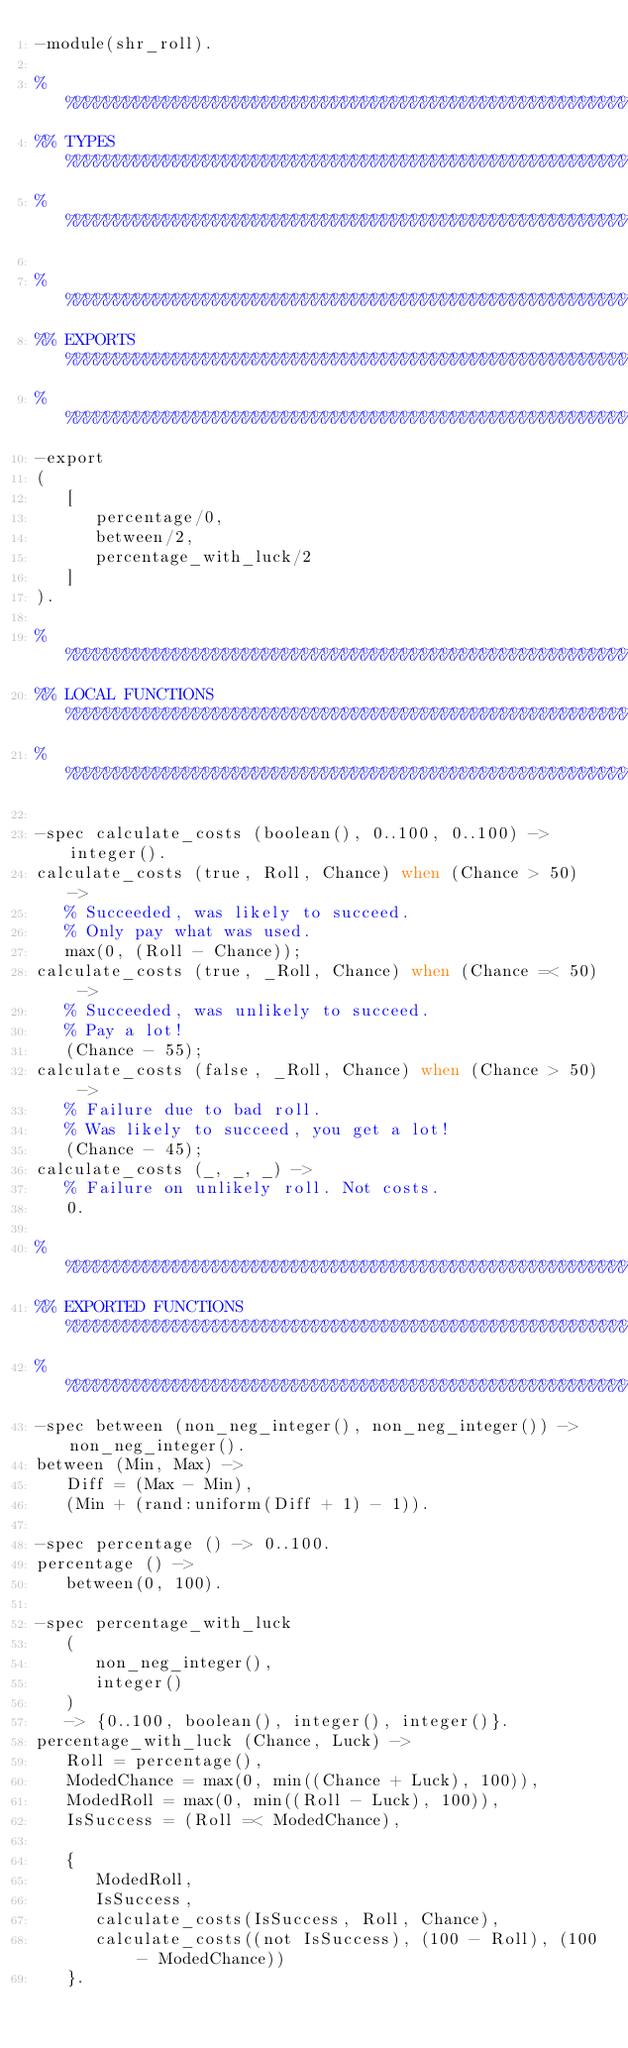<code> <loc_0><loc_0><loc_500><loc_500><_Erlang_>-module(shr_roll).

%%%%%%%%%%%%%%%%%%%%%%%%%%%%%%%%%%%%%%%%%%%%%%%%%%%%%%%%%%%%%%%%%%%%%%%%%%%%%%%%
%% TYPES %%%%%%%%%%%%%%%%%%%%%%%%%%%%%%%%%%%%%%%%%%%%%%%%%%%%%%%%%%%%%%%%%%%%%%%
%%%%%%%%%%%%%%%%%%%%%%%%%%%%%%%%%%%%%%%%%%%%%%%%%%%%%%%%%%%%%%%%%%%%%%%%%%%%%%%%

%%%%%%%%%%%%%%%%%%%%%%%%%%%%%%%%%%%%%%%%%%%%%%%%%%%%%%%%%%%%%%%%%%%%%%%%%%%%%%%%
%% EXPORTS %%%%%%%%%%%%%%%%%%%%%%%%%%%%%%%%%%%%%%%%%%%%%%%%%%%%%%%%%%%%%%%%%%%%%
%%%%%%%%%%%%%%%%%%%%%%%%%%%%%%%%%%%%%%%%%%%%%%%%%%%%%%%%%%%%%%%%%%%%%%%%%%%%%%%%
-export
(
   [
      percentage/0,
      between/2,
      percentage_with_luck/2
   ]
).

%%%%%%%%%%%%%%%%%%%%%%%%%%%%%%%%%%%%%%%%%%%%%%%%%%%%%%%%%%%%%%%%%%%%%%%%%%%%%%%%
%% LOCAL FUNCTIONS %%%%%%%%%%%%%%%%%%%%%%%%%%%%%%%%%%%%%%%%%%%%%%%%%%%%%%%%%%%%%
%%%%%%%%%%%%%%%%%%%%%%%%%%%%%%%%%%%%%%%%%%%%%%%%%%%%%%%%%%%%%%%%%%%%%%%%%%%%%%%%

-spec calculate_costs (boolean(), 0..100, 0..100) -> integer().
calculate_costs (true, Roll, Chance) when (Chance > 50) ->
   % Succeeded, was likely to succeed.
   % Only pay what was used.
   max(0, (Roll - Chance));
calculate_costs (true, _Roll, Chance) when (Chance =< 50) ->
   % Succeeded, was unlikely to succeed.
   % Pay a lot!
   (Chance - 55);
calculate_costs (false, _Roll, Chance) when (Chance > 50) ->
   % Failure due to bad roll.
   % Was likely to succeed, you get a lot!
   (Chance - 45);
calculate_costs (_, _, _) ->
   % Failure on unlikely roll. Not costs.
   0.

%%%%%%%%%%%%%%%%%%%%%%%%%%%%%%%%%%%%%%%%%%%%%%%%%%%%%%%%%%%%%%%%%%%%%%%%%%%%%%%%
%% EXPORTED FUNCTIONS %%%%%%%%%%%%%%%%%%%%%%%%%%%%%%%%%%%%%%%%%%%%%%%%%%%%%%%%%%
%%%%%%%%%%%%%%%%%%%%%%%%%%%%%%%%%%%%%%%%%%%%%%%%%%%%%%%%%%%%%%%%%%%%%%%%%%%%%%%%
-spec between (non_neg_integer(), non_neg_integer()) -> non_neg_integer().
between (Min, Max) ->
   Diff = (Max - Min),
   (Min + (rand:uniform(Diff + 1) - 1)).

-spec percentage () -> 0..100.
percentage () ->
   between(0, 100).

-spec percentage_with_luck
   (
      non_neg_integer(),
      integer()
   )
   -> {0..100, boolean(), integer(), integer()}.
percentage_with_luck (Chance, Luck) ->
   Roll = percentage(),
   ModedChance = max(0, min((Chance + Luck), 100)),
   ModedRoll = max(0, min((Roll - Luck), 100)),
   IsSuccess = (Roll =< ModedChance),

   {
      ModedRoll,
      IsSuccess,
      calculate_costs(IsSuccess, Roll, Chance),
      calculate_costs((not IsSuccess), (100 - Roll), (100 - ModedChance))
   }.
</code> 